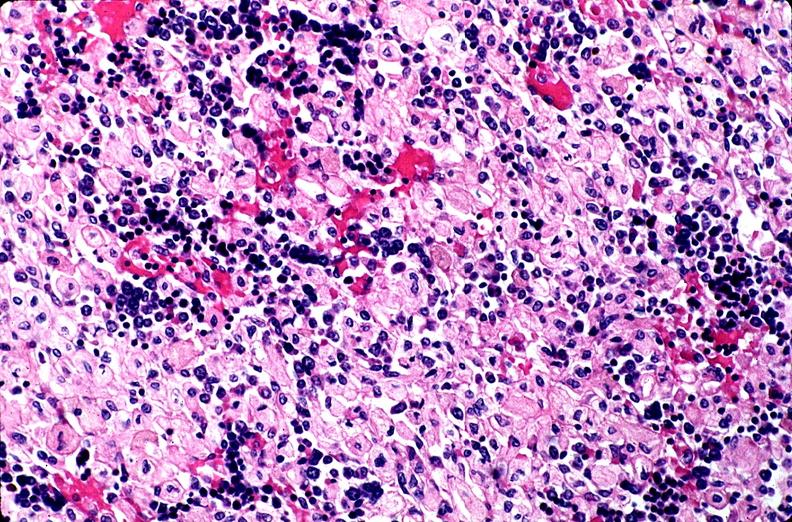what is present?
Answer the question using a single word or phrase. Hematologic 